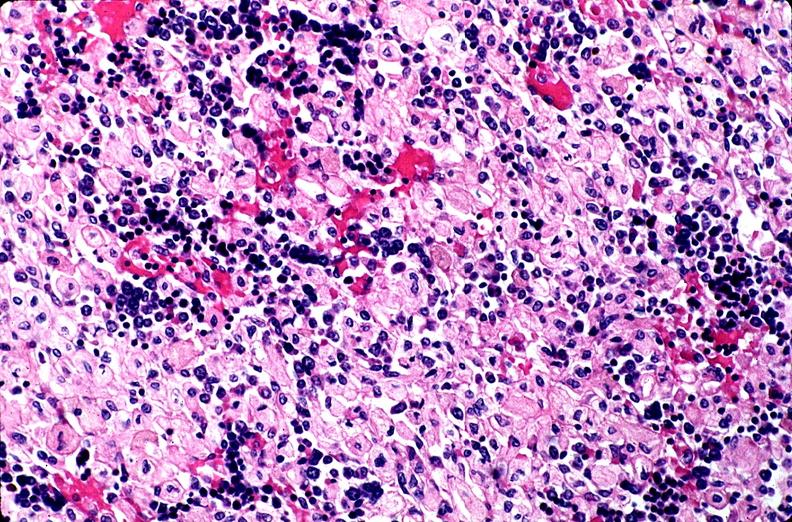what is present?
Answer the question using a single word or phrase. Hematologic 